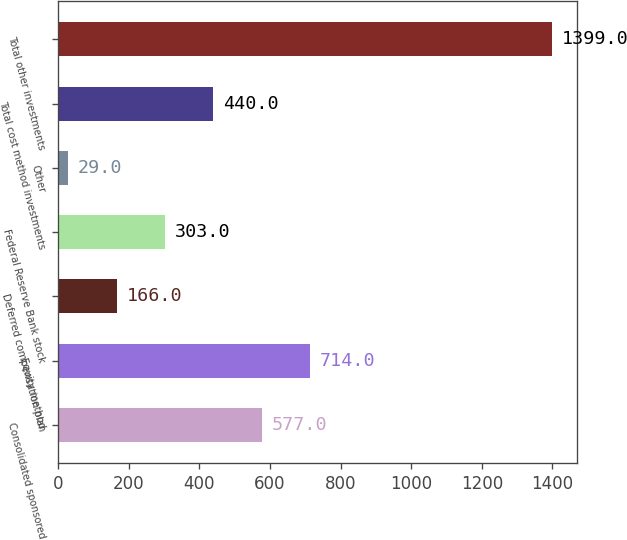Convert chart to OTSL. <chart><loc_0><loc_0><loc_500><loc_500><bar_chart><fcel>Consolidated sponsored<fcel>Equity method<fcel>Deferred compensation plan<fcel>Federal Reserve Bank stock<fcel>Other<fcel>Total cost method investments<fcel>Total other investments<nl><fcel>577<fcel>714<fcel>166<fcel>303<fcel>29<fcel>440<fcel>1399<nl></chart> 